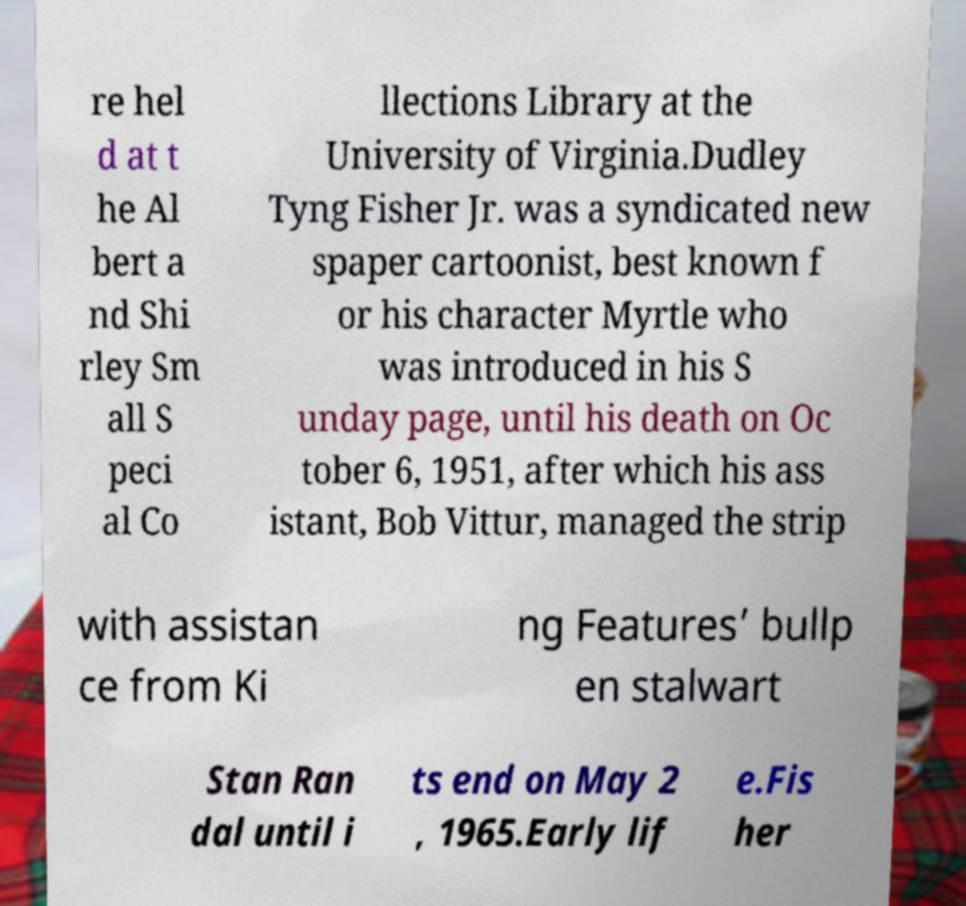Please read and relay the text visible in this image. What does it say? re hel d at t he Al bert a nd Shi rley Sm all S peci al Co llections Library at the University of Virginia.Dudley Tyng Fisher Jr. was a syndicated new spaper cartoonist, best known f or his character Myrtle who was introduced in his S unday page, until his death on Oc tober 6, 1951, after which his ass istant, Bob Vittur, managed the strip with assistan ce from Ki ng Features’ bullp en stalwart Stan Ran dal until i ts end on May 2 , 1965.Early lif e.Fis her 